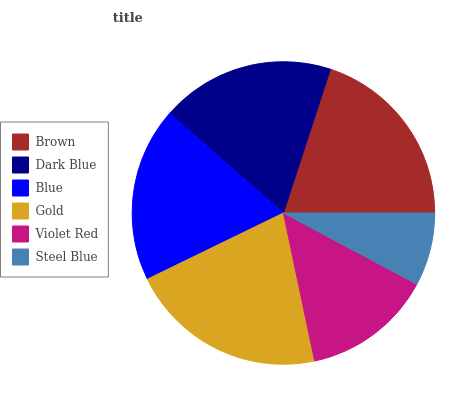Is Steel Blue the minimum?
Answer yes or no. Yes. Is Gold the maximum?
Answer yes or no. Yes. Is Dark Blue the minimum?
Answer yes or no. No. Is Dark Blue the maximum?
Answer yes or no. No. Is Brown greater than Dark Blue?
Answer yes or no. Yes. Is Dark Blue less than Brown?
Answer yes or no. Yes. Is Dark Blue greater than Brown?
Answer yes or no. No. Is Brown less than Dark Blue?
Answer yes or no. No. Is Blue the high median?
Answer yes or no. Yes. Is Dark Blue the low median?
Answer yes or no. Yes. Is Violet Red the high median?
Answer yes or no. No. Is Gold the low median?
Answer yes or no. No. 